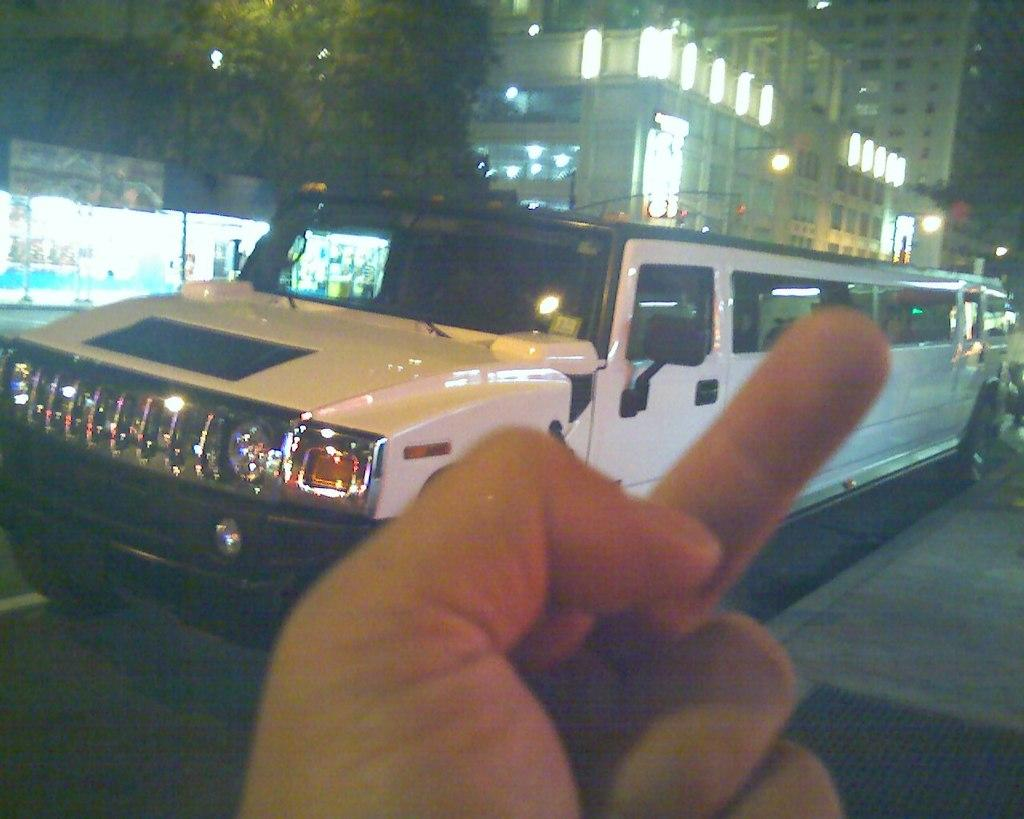What part of a person can be seen in the image? There is a person's hand in the image. What type of car is visible in the image? There is a white and black car in the image. Where is the car located in the image? The car is on the road. What can be seen in the background of the image? There are stores, trees, buildings, and lights in the background of the image. Can you see a quill being used to write in the image? There is no quill or writing activity present in the image. Is there a harbor visible in the background of the image? There is no harbor present in the image; only stores, trees, buildings, and lights can be seen in the background. 